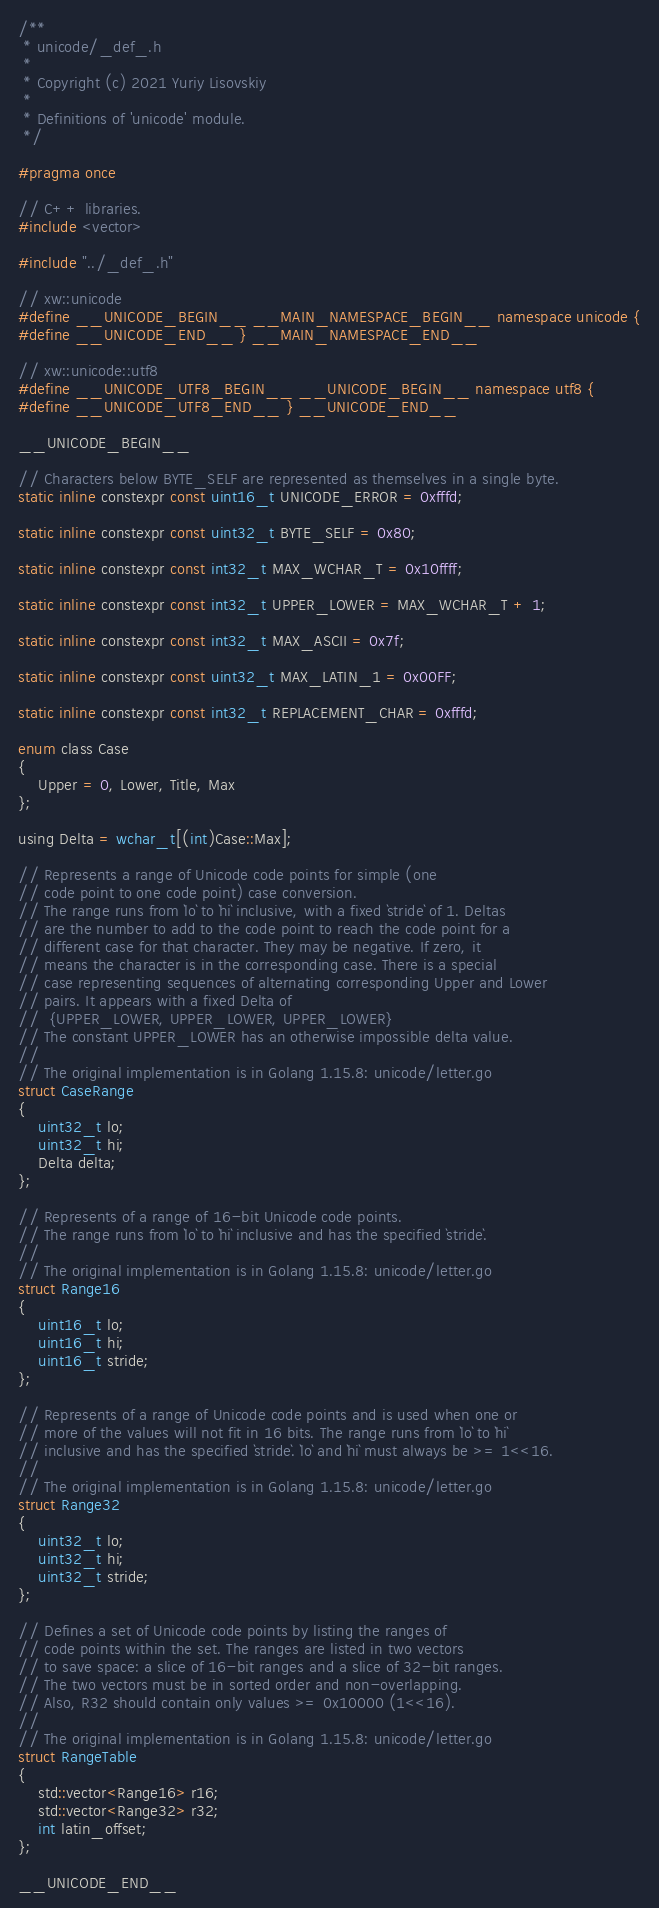Convert code to text. <code><loc_0><loc_0><loc_500><loc_500><_C_>/**
 * unicode/_def_.h
 *
 * Copyright (c) 2021 Yuriy Lisovskiy
 *
 * Definitions of 'unicode' module.
 */

#pragma once

// C++ libraries.
#include <vector>

#include "../_def_.h"

// xw::unicode
#define __UNICODE_BEGIN__ __MAIN_NAMESPACE_BEGIN__ namespace unicode {
#define __UNICODE_END__ } __MAIN_NAMESPACE_END__

// xw::unicode::utf8
#define __UNICODE_UTF8_BEGIN__ __UNICODE_BEGIN__ namespace utf8 {
#define __UNICODE_UTF8_END__ } __UNICODE_END__

__UNICODE_BEGIN__

// Characters below BYTE_SELF are represented as themselves in a single byte.
static inline constexpr const uint16_t UNICODE_ERROR = 0xfffd;

static inline constexpr const uint32_t BYTE_SELF = 0x80;

static inline constexpr const int32_t MAX_WCHAR_T = 0x10ffff;

static inline constexpr const int32_t UPPER_LOWER = MAX_WCHAR_T + 1;

static inline constexpr const int32_t MAX_ASCII = 0x7f;

static inline constexpr const uint32_t MAX_LATIN_1 = 0x00FF;

static inline constexpr const int32_t REPLACEMENT_CHAR = 0xfffd;

enum class Case
{
	Upper = 0, Lower, Title, Max
};

using Delta = wchar_t[(int)Case::Max];

// Represents a range of Unicode code points for simple (one
// code point to one code point) case conversion.
// The range runs from `lo` to `hi` inclusive, with a fixed `stride` of 1. Deltas
// are the number to add to the code point to reach the code point for a
// different case for that character. They may be negative. If zero, it
// means the character is in the corresponding case. There is a special
// case representing sequences of alternating corresponding Upper and Lower
// pairs. It appears with a fixed Delta of
//	{UPPER_LOWER, UPPER_LOWER, UPPER_LOWER}
// The constant UPPER_LOWER has an otherwise impossible delta value.
//
// The original implementation is in Golang 1.15.8: unicode/letter.go
struct CaseRange
{
	uint32_t lo;
	uint32_t hi;
	Delta delta;
};

// Represents of a range of 16-bit Unicode code points.
// The range runs from `lo` to `hi` inclusive and has the specified `stride`.
//
// The original implementation is in Golang 1.15.8: unicode/letter.go
struct Range16
{
	uint16_t lo;
	uint16_t hi;
	uint16_t stride;
};

// Represents of a range of Unicode code points and is used when one or
// more of the values will not fit in 16 bits. The range runs from `lo` to `hi`
// inclusive and has the specified `stride`. `lo` and `hi` must always be >= 1<<16.
//
// The original implementation is in Golang 1.15.8: unicode/letter.go
struct Range32
{
	uint32_t lo;
	uint32_t hi;
	uint32_t stride;
};

// Defines a set of Unicode code points by listing the ranges of
// code points within the set. The ranges are listed in two vectors
// to save space: a slice of 16-bit ranges and a slice of 32-bit ranges.
// The two vectors must be in sorted order and non-overlapping.
// Also, R32 should contain only values >= 0x10000 (1<<16).
//
// The original implementation is in Golang 1.15.8: unicode/letter.go
struct RangeTable
{
	std::vector<Range16> r16;
	std::vector<Range32> r32;
	int latin_offset;
};

__UNICODE_END__
</code> 